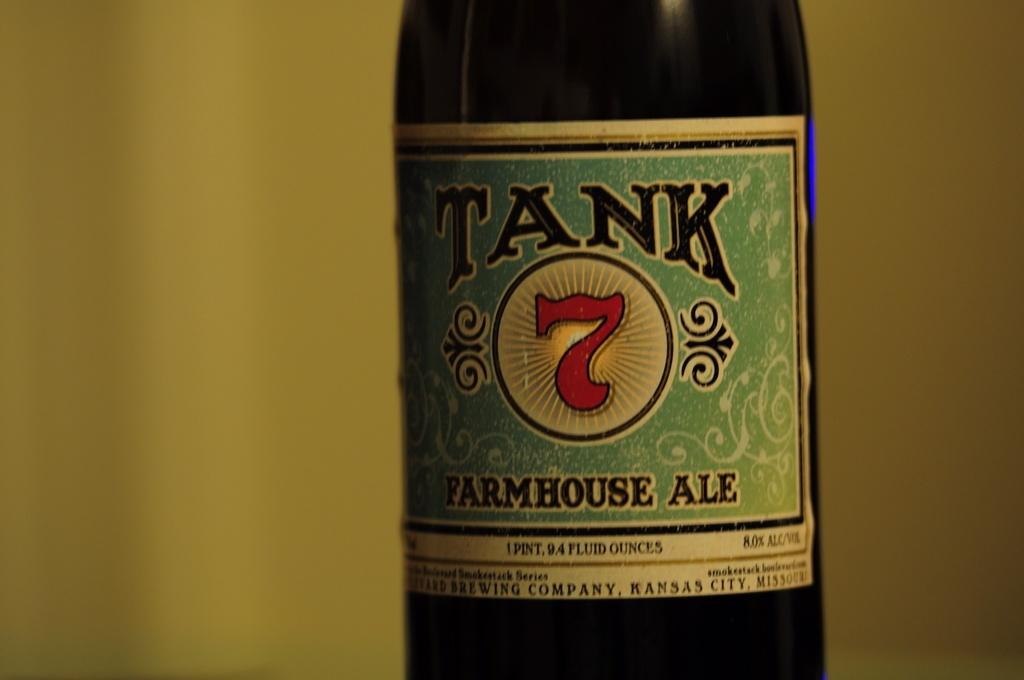<image>
Provide a brief description of the given image. Tank is a type of Farmhouse Ale that is drinkable. 